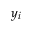<formula> <loc_0><loc_0><loc_500><loc_500>y _ { i }</formula> 